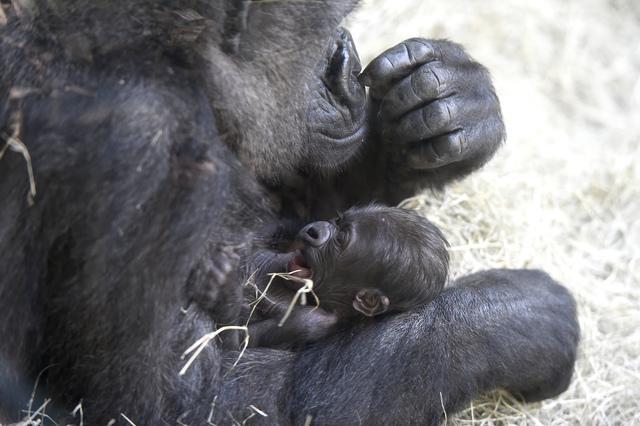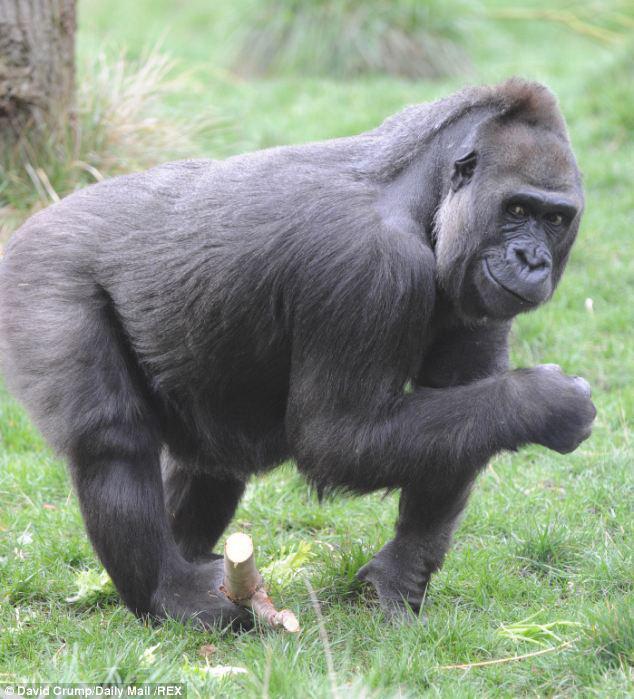The first image is the image on the left, the second image is the image on the right. Analyze the images presented: Is the assertion "Atleast one photo has a baby monkey looking to the right" valid? Answer yes or no. No. The first image is the image on the left, the second image is the image on the right. Considering the images on both sides, is "The left image shows a mother gorilla's bent arm around a baby gorilla held to her chest and her other arm held up to her face." valid? Answer yes or no. Yes. The first image is the image on the left, the second image is the image on the right. Considering the images on both sides, is "A gorilla is holding a baby gorilla in its arms." valid? Answer yes or no. Yes. The first image is the image on the left, the second image is the image on the right. For the images shown, is this caption "One of the gorillas is touching its face with its left hand." true? Answer yes or no. Yes. 